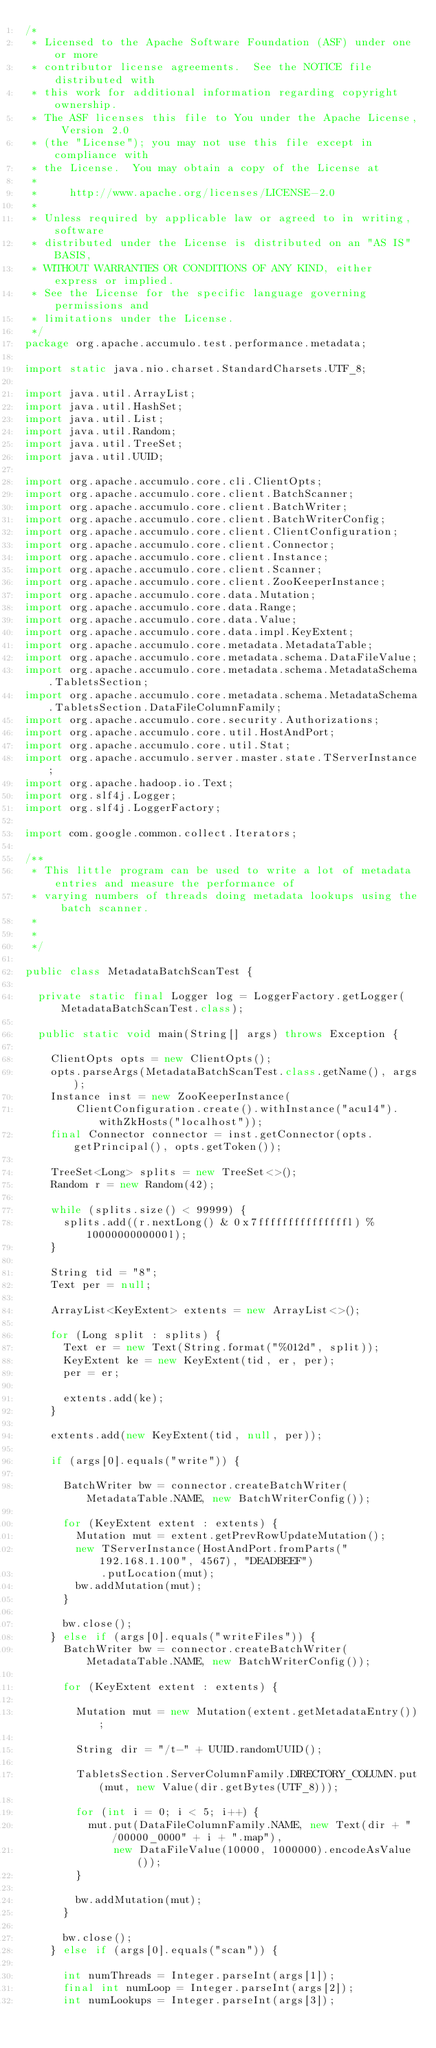Convert code to text. <code><loc_0><loc_0><loc_500><loc_500><_Java_>/*
 * Licensed to the Apache Software Foundation (ASF) under one or more
 * contributor license agreements.  See the NOTICE file distributed with
 * this work for additional information regarding copyright ownership.
 * The ASF licenses this file to You under the Apache License, Version 2.0
 * (the "License"); you may not use this file except in compliance with
 * the License.  You may obtain a copy of the License at
 *
 *     http://www.apache.org/licenses/LICENSE-2.0
 *
 * Unless required by applicable law or agreed to in writing, software
 * distributed under the License is distributed on an "AS IS" BASIS,
 * WITHOUT WARRANTIES OR CONDITIONS OF ANY KIND, either express or implied.
 * See the License for the specific language governing permissions and
 * limitations under the License.
 */
package org.apache.accumulo.test.performance.metadata;

import static java.nio.charset.StandardCharsets.UTF_8;

import java.util.ArrayList;
import java.util.HashSet;
import java.util.List;
import java.util.Random;
import java.util.TreeSet;
import java.util.UUID;

import org.apache.accumulo.core.cli.ClientOpts;
import org.apache.accumulo.core.client.BatchScanner;
import org.apache.accumulo.core.client.BatchWriter;
import org.apache.accumulo.core.client.BatchWriterConfig;
import org.apache.accumulo.core.client.ClientConfiguration;
import org.apache.accumulo.core.client.Connector;
import org.apache.accumulo.core.client.Instance;
import org.apache.accumulo.core.client.Scanner;
import org.apache.accumulo.core.client.ZooKeeperInstance;
import org.apache.accumulo.core.data.Mutation;
import org.apache.accumulo.core.data.Range;
import org.apache.accumulo.core.data.Value;
import org.apache.accumulo.core.data.impl.KeyExtent;
import org.apache.accumulo.core.metadata.MetadataTable;
import org.apache.accumulo.core.metadata.schema.DataFileValue;
import org.apache.accumulo.core.metadata.schema.MetadataSchema.TabletsSection;
import org.apache.accumulo.core.metadata.schema.MetadataSchema.TabletsSection.DataFileColumnFamily;
import org.apache.accumulo.core.security.Authorizations;
import org.apache.accumulo.core.util.HostAndPort;
import org.apache.accumulo.core.util.Stat;
import org.apache.accumulo.server.master.state.TServerInstance;
import org.apache.hadoop.io.Text;
import org.slf4j.Logger;
import org.slf4j.LoggerFactory;

import com.google.common.collect.Iterators;

/**
 * This little program can be used to write a lot of metadata entries and measure the performance of
 * varying numbers of threads doing metadata lookups using the batch scanner.
 *
 *
 */

public class MetadataBatchScanTest {

  private static final Logger log = LoggerFactory.getLogger(MetadataBatchScanTest.class);

  public static void main(String[] args) throws Exception {

    ClientOpts opts = new ClientOpts();
    opts.parseArgs(MetadataBatchScanTest.class.getName(), args);
    Instance inst = new ZooKeeperInstance(
        ClientConfiguration.create().withInstance("acu14").withZkHosts("localhost"));
    final Connector connector = inst.getConnector(opts.getPrincipal(), opts.getToken());

    TreeSet<Long> splits = new TreeSet<>();
    Random r = new Random(42);

    while (splits.size() < 99999) {
      splits.add((r.nextLong() & 0x7fffffffffffffffl) % 1000000000000l);
    }

    String tid = "8";
    Text per = null;

    ArrayList<KeyExtent> extents = new ArrayList<>();

    for (Long split : splits) {
      Text er = new Text(String.format("%012d", split));
      KeyExtent ke = new KeyExtent(tid, er, per);
      per = er;

      extents.add(ke);
    }

    extents.add(new KeyExtent(tid, null, per));

    if (args[0].equals("write")) {

      BatchWriter bw = connector.createBatchWriter(MetadataTable.NAME, new BatchWriterConfig());

      for (KeyExtent extent : extents) {
        Mutation mut = extent.getPrevRowUpdateMutation();
        new TServerInstance(HostAndPort.fromParts("192.168.1.100", 4567), "DEADBEEF")
            .putLocation(mut);
        bw.addMutation(mut);
      }

      bw.close();
    } else if (args[0].equals("writeFiles")) {
      BatchWriter bw = connector.createBatchWriter(MetadataTable.NAME, new BatchWriterConfig());

      for (KeyExtent extent : extents) {

        Mutation mut = new Mutation(extent.getMetadataEntry());

        String dir = "/t-" + UUID.randomUUID();

        TabletsSection.ServerColumnFamily.DIRECTORY_COLUMN.put(mut, new Value(dir.getBytes(UTF_8)));

        for (int i = 0; i < 5; i++) {
          mut.put(DataFileColumnFamily.NAME, new Text(dir + "/00000_0000" + i + ".map"),
              new DataFileValue(10000, 1000000).encodeAsValue());
        }

        bw.addMutation(mut);
      }

      bw.close();
    } else if (args[0].equals("scan")) {

      int numThreads = Integer.parseInt(args[1]);
      final int numLoop = Integer.parseInt(args[2]);
      int numLookups = Integer.parseInt(args[3]);
</code> 